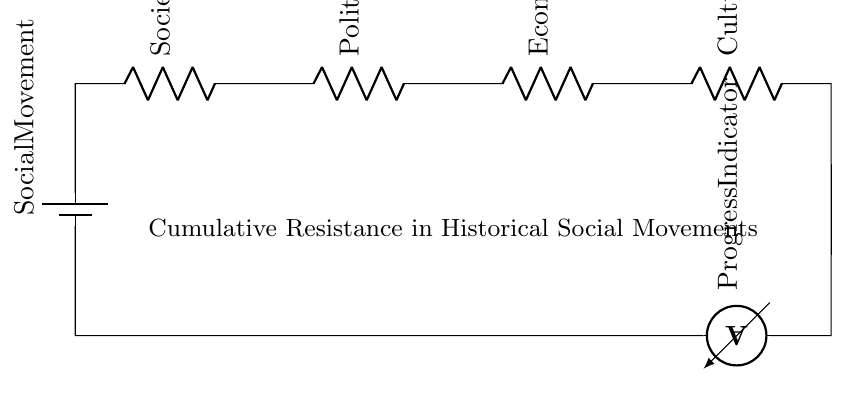What is the total number of resistors in this circuit? There are four resistors in the circuit, each representing a form of resistance to social movements.
Answer: four What does the battery represent in the circuit? The battery symbolizes the social movement's drive or motivation, providing the initial energy to challenge resistances.
Answer: social movement What is indicated by the ammeter in the circuit? The ammeter measures the flow of progress in the social movement, showing how much advancement is being made despite the resistances.
Answer: progress indicator Which type of resistance is first in the series? The first resistance in the series is societal inertia, indicating the initial pushback against change in social movements.
Answer: societal inertia If one additional resistor is added to the circuit, what happens to the total resistance? Adding another resistor in series would increase the total resistance, as resistances in series sum up.
Answer: increase How many types of resistance are represented in the circuit? There are four types of resistance represented: societal inertia, political opposition, economic barriers, and cultural resistance.
Answer: four What does the term "cumulative resistance" refer to in this circuit? Cumulative resistance refers to the total opposition faced by a social movement due to various resistances combined in series, affecting its progress.
Answer: total opposition 